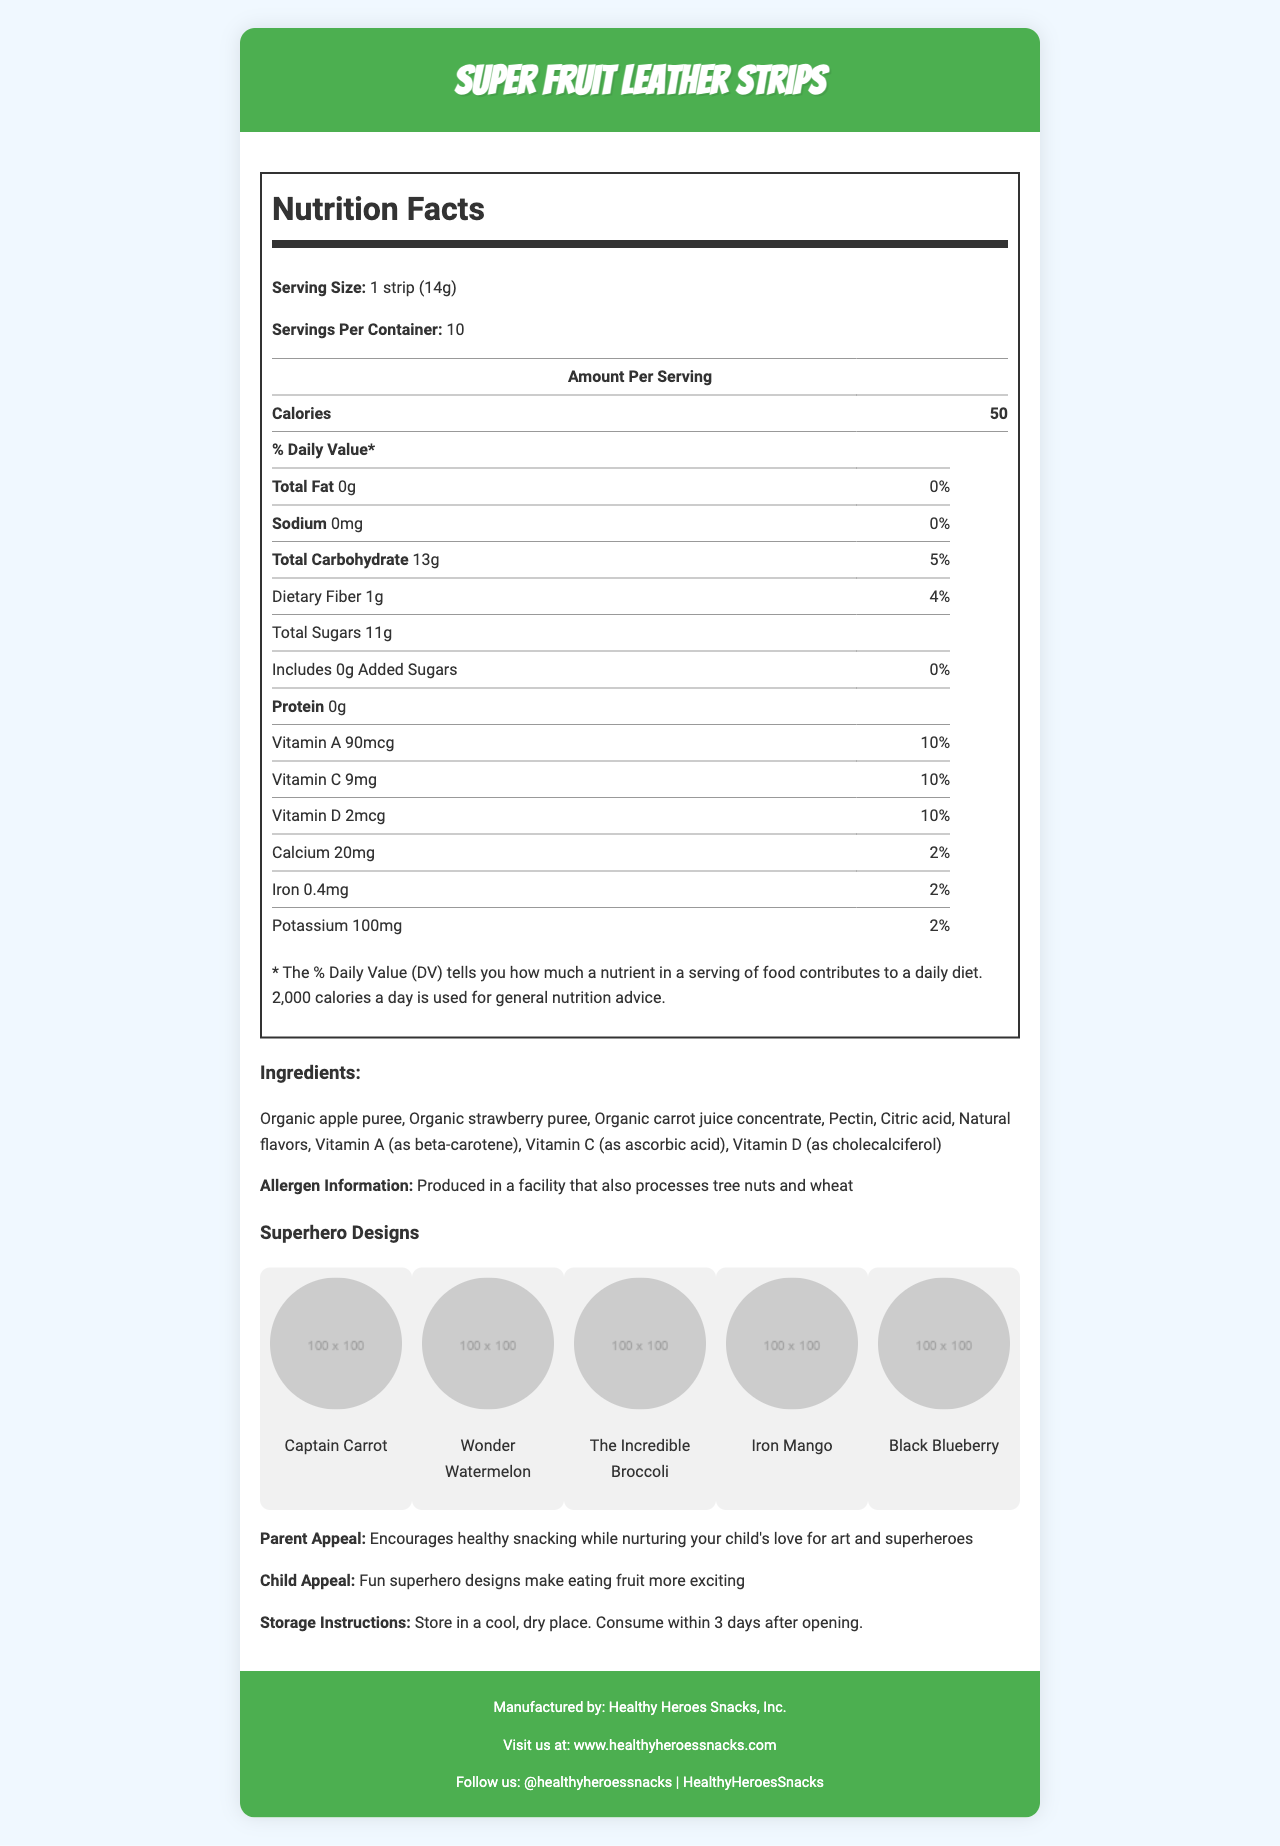What is the serving size for Super Fruit Leather Strips? The serving size is listed as "1 strip (14g)" in the Nutrition Facts section.
Answer: 1 strip (14g) How many servings are there per container? The document states that there are 10 servings per container.
Answer: 10 How many calories are in one serving of the fruit leather strips? The Calories section in the Nutrition Facts indicates that each serving contains 50 calories.
Answer: 50 What is the total carbohydrate content per serving? The Total Carbohydrate content is listed as 13g in the Nutrition Facts section.
Answer: 13g Which vitamins are included in the fruit leather strips? The Nutrition Facts label lists Vitamin A, Vitamin C, and Vitamin D with their respective amounts and daily values.
Answer: Vitamin A, Vitamin C, Vitamin D What percentage of the daily value for Vitamin A does one serving provide? The Nutrition Facts label shows that Vitamin A provides 10% of the daily value per serving.
Answer: 10% What is the sodium content in one serving of these fruit leather strips? The sodium content is listed as 0mg in the Nutrition Facts section.
Answer: 0mg How much dietary fiber is included in a serving? A. 1g B. 2g C. 3g D. 4g The dietary fiber content is listed as 1g per serving in the Nutrition Facts section.
Answer: A. 1g Which ingredient is used as a source of Vitamin A? A. Organic apple puree B. Organic strawberry puree C. Beta-carotene D. Citric acid The ingredient list specifies that Vitamin A is provided as beta-carotene.
Answer: C. Beta-carotene Are there any added sugars in the fruit leather strips? The Nutrition Facts state that the strips contain 0g of added sugars.
Answer: No Is the product suitable for someone with a tree nut allergy? The allergen information indicates that it is produced in a facility that processes tree nuts.
Answer: No What are the superhero designs featured on the fruit leather strips? The superhero designs listed are Captain Carrot, Wonder Watermelon, The Incredible Broccoli, Iron Mango, and Black Blueberry.
Answer: Captain Carrot, Wonder Watermelon, The Incredible Broccoli, Iron Mango, Black Blueberry What storage instructions are given for the fruit leather strips? The storage instructions are to store in a cool, dry place and consume within 3 days after opening.
Answer: Store in a cool, dry place. Consume within 3 days after opening. What is the manufacturer of the Super Fruit Leather Strips? The document states that the manufacturer is Healthy Heroes Snacks, Inc.
Answer: Healthy Heroes Snacks, Inc. Summarize the main appeal of the product for parents. The parent appeal section highlights that the product encourages healthy snacking and nurtures a child's passion for art and superheroes.
Answer: Encourages healthy snacking while nurturing your child's love for art and superheroes Which social media platforms does Healthy Heroes Snacks, Inc. use? The footer lists Instagram (@healthyheroessnacks) and Facebook (HealthyHeroesSnacks) as their social media platforms.
Answer: Instagram and Facebook What is the effect of citric acid in the fruit leather strips? The document doesn't provide enough information to determine the effect of citric acid in the fruit leather strips.
Answer: Cannot be determined 